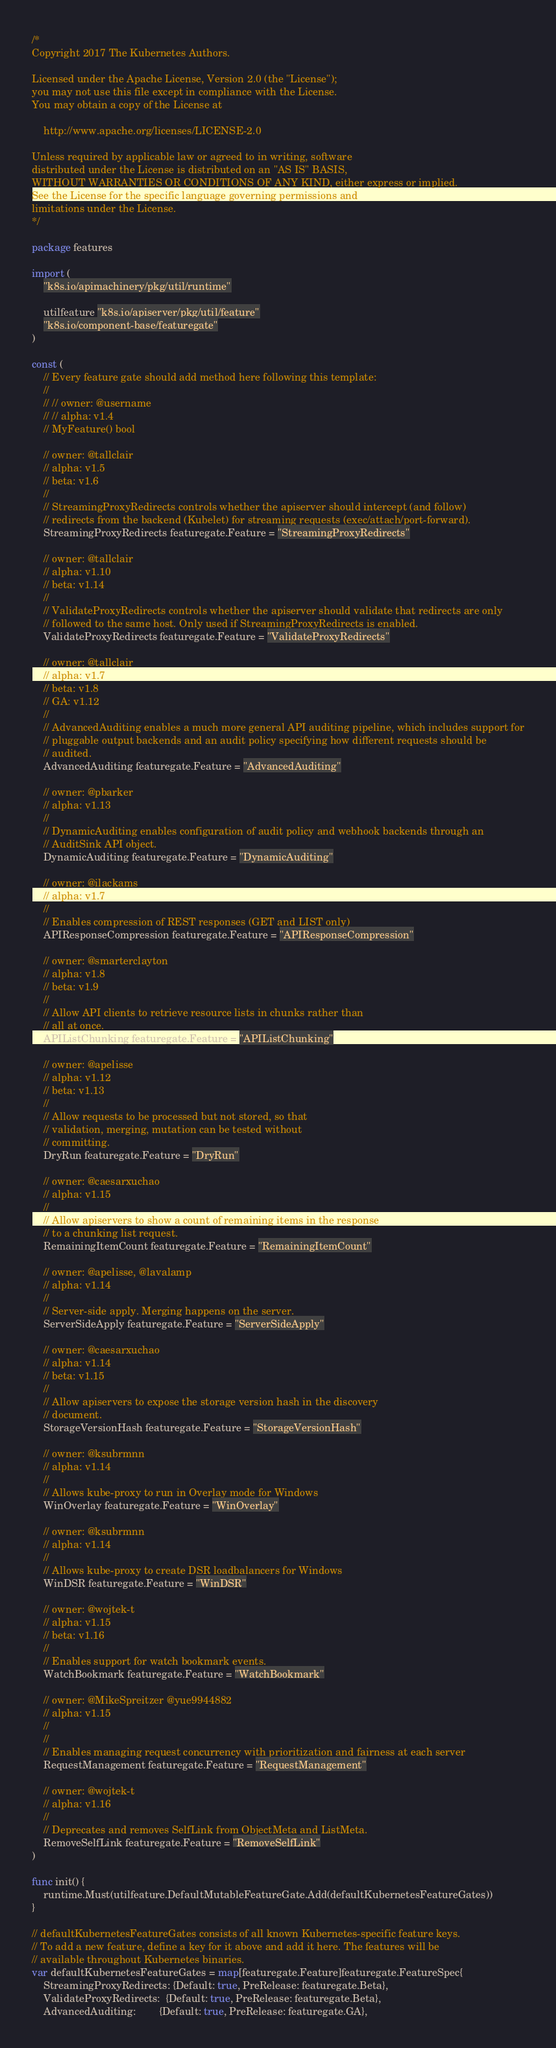Convert code to text. <code><loc_0><loc_0><loc_500><loc_500><_Go_>/*
Copyright 2017 The Kubernetes Authors.

Licensed under the Apache License, Version 2.0 (the "License");
you may not use this file except in compliance with the License.
You may obtain a copy of the License at

    http://www.apache.org/licenses/LICENSE-2.0

Unless required by applicable law or agreed to in writing, software
distributed under the License is distributed on an "AS IS" BASIS,
WITHOUT WARRANTIES OR CONDITIONS OF ANY KIND, either express or implied.
See the License for the specific language governing permissions and
limitations under the License.
*/

package features

import (
	"k8s.io/apimachinery/pkg/util/runtime"

	utilfeature "k8s.io/apiserver/pkg/util/feature"
	"k8s.io/component-base/featuregate"
)

const (
	// Every feature gate should add method here following this template:
	//
	// // owner: @username
	// // alpha: v1.4
	// MyFeature() bool

	// owner: @tallclair
	// alpha: v1.5
	// beta: v1.6
	//
	// StreamingProxyRedirects controls whether the apiserver should intercept (and follow)
	// redirects from the backend (Kubelet) for streaming requests (exec/attach/port-forward).
	StreamingProxyRedirects featuregate.Feature = "StreamingProxyRedirects"

	// owner: @tallclair
	// alpha: v1.10
	// beta: v1.14
	//
	// ValidateProxyRedirects controls whether the apiserver should validate that redirects are only
	// followed to the same host. Only used if StreamingProxyRedirects is enabled.
	ValidateProxyRedirects featuregate.Feature = "ValidateProxyRedirects"

	// owner: @tallclair
	// alpha: v1.7
	// beta: v1.8
	// GA: v1.12
	//
	// AdvancedAuditing enables a much more general API auditing pipeline, which includes support for
	// pluggable output backends and an audit policy specifying how different requests should be
	// audited.
	AdvancedAuditing featuregate.Feature = "AdvancedAuditing"

	// owner: @pbarker
	// alpha: v1.13
	//
	// DynamicAuditing enables configuration of audit policy and webhook backends through an
	// AuditSink API object.
	DynamicAuditing featuregate.Feature = "DynamicAuditing"

	// owner: @ilackams
	// alpha: v1.7
	//
	// Enables compression of REST responses (GET and LIST only)
	APIResponseCompression featuregate.Feature = "APIResponseCompression"

	// owner: @smarterclayton
	// alpha: v1.8
	// beta: v1.9
	//
	// Allow API clients to retrieve resource lists in chunks rather than
	// all at once.
	APIListChunking featuregate.Feature = "APIListChunking"

	// owner: @apelisse
	// alpha: v1.12
	// beta: v1.13
	//
	// Allow requests to be processed but not stored, so that
	// validation, merging, mutation can be tested without
	// committing.
	DryRun featuregate.Feature = "DryRun"

	// owner: @caesarxuchao
	// alpha: v1.15
	//
	// Allow apiservers to show a count of remaining items in the response
	// to a chunking list request.
	RemainingItemCount featuregate.Feature = "RemainingItemCount"

	// owner: @apelisse, @lavalamp
	// alpha: v1.14
	//
	// Server-side apply. Merging happens on the server.
	ServerSideApply featuregate.Feature = "ServerSideApply"

	// owner: @caesarxuchao
	// alpha: v1.14
	// beta: v1.15
	//
	// Allow apiservers to expose the storage version hash in the discovery
	// document.
	StorageVersionHash featuregate.Feature = "StorageVersionHash"

	// owner: @ksubrmnn
	// alpha: v1.14
	//
	// Allows kube-proxy to run in Overlay mode for Windows
	WinOverlay featuregate.Feature = "WinOverlay"

	// owner: @ksubrmnn
	// alpha: v1.14
	//
	// Allows kube-proxy to create DSR loadbalancers for Windows
	WinDSR featuregate.Feature = "WinDSR"

	// owner: @wojtek-t
	// alpha: v1.15
	// beta: v1.16
	//
	// Enables support for watch bookmark events.
	WatchBookmark featuregate.Feature = "WatchBookmark"

	// owner: @MikeSpreitzer @yue9944882
	// alpha: v1.15
	//
	//
	// Enables managing request concurrency with prioritization and fairness at each server
	RequestManagement featuregate.Feature = "RequestManagement"

	// owner: @wojtek-t
	// alpha: v1.16
	//
	// Deprecates and removes SelfLink from ObjectMeta and ListMeta.
	RemoveSelfLink featuregate.Feature = "RemoveSelfLink"
)

func init() {
	runtime.Must(utilfeature.DefaultMutableFeatureGate.Add(defaultKubernetesFeatureGates))
}

// defaultKubernetesFeatureGates consists of all known Kubernetes-specific feature keys.
// To add a new feature, define a key for it above and add it here. The features will be
// available throughout Kubernetes binaries.
var defaultKubernetesFeatureGates = map[featuregate.Feature]featuregate.FeatureSpec{
	StreamingProxyRedirects: {Default: true, PreRelease: featuregate.Beta},
	ValidateProxyRedirects:  {Default: true, PreRelease: featuregate.Beta},
	AdvancedAuditing:        {Default: true, PreRelease: featuregate.GA},</code> 